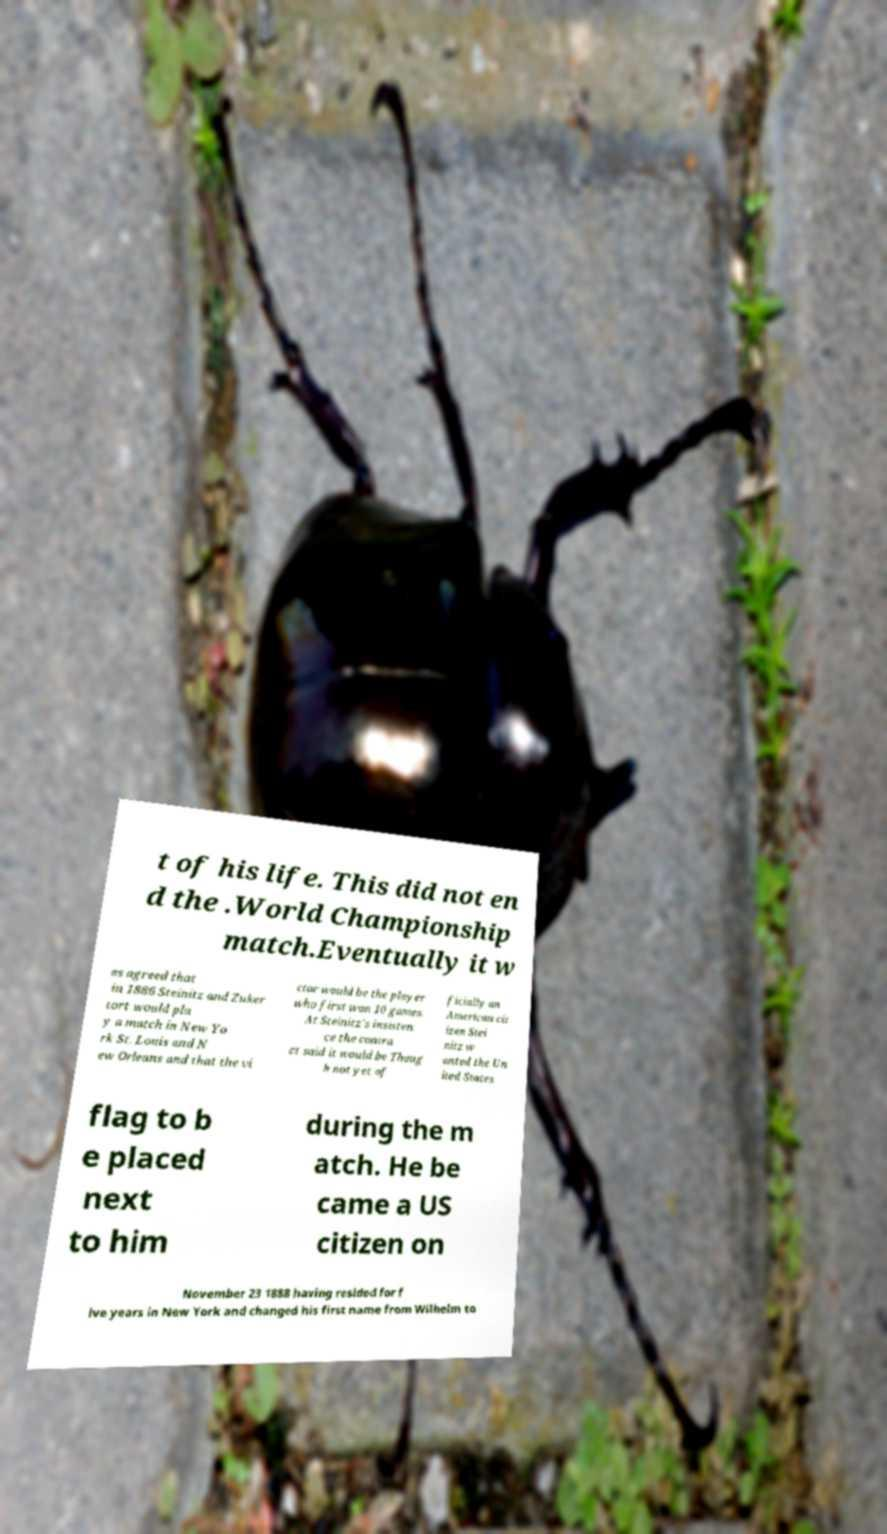There's text embedded in this image that I need extracted. Can you transcribe it verbatim? t of his life. This did not en d the .World Championship match.Eventually it w as agreed that in 1886 Steinitz and Zuker tort would pla y a match in New Yo rk St. Louis and N ew Orleans and that the vi ctor would be the player who first won 10 games. At Steinitz's insisten ce the contra ct said it would be Thoug h not yet of ficially an American cit izen Stei nitz w anted the Un ited States flag to b e placed next to him during the m atch. He be came a US citizen on November 23 1888 having resided for f ive years in New York and changed his first name from Wilhelm to 